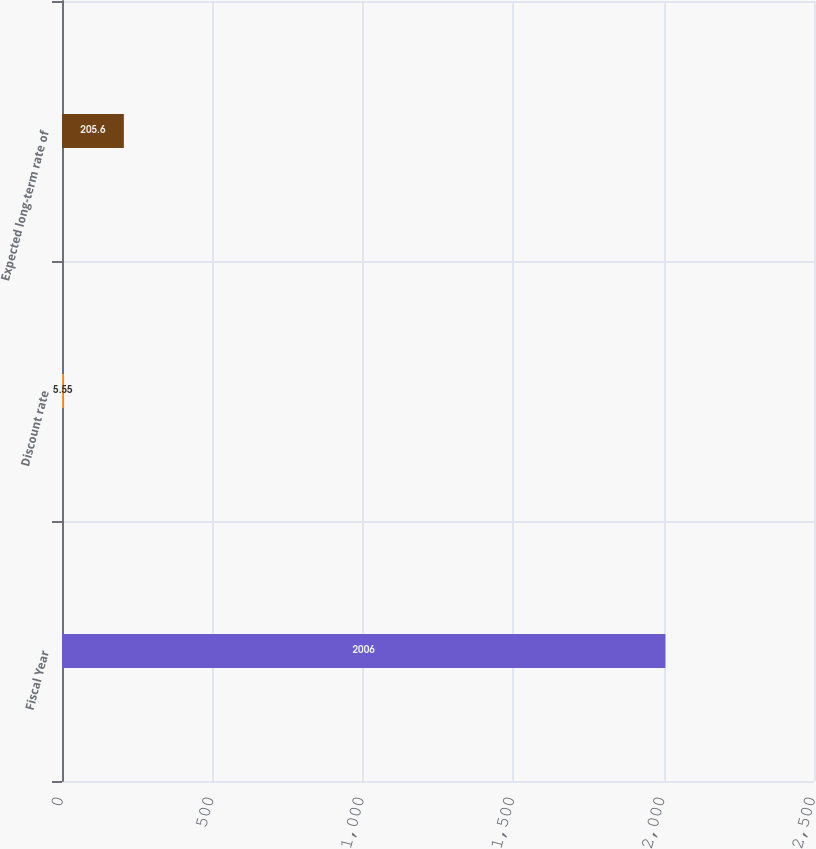Convert chart. <chart><loc_0><loc_0><loc_500><loc_500><bar_chart><fcel>Fiscal Year<fcel>Discount rate<fcel>Expected long-term rate of<nl><fcel>2006<fcel>5.55<fcel>205.6<nl></chart> 